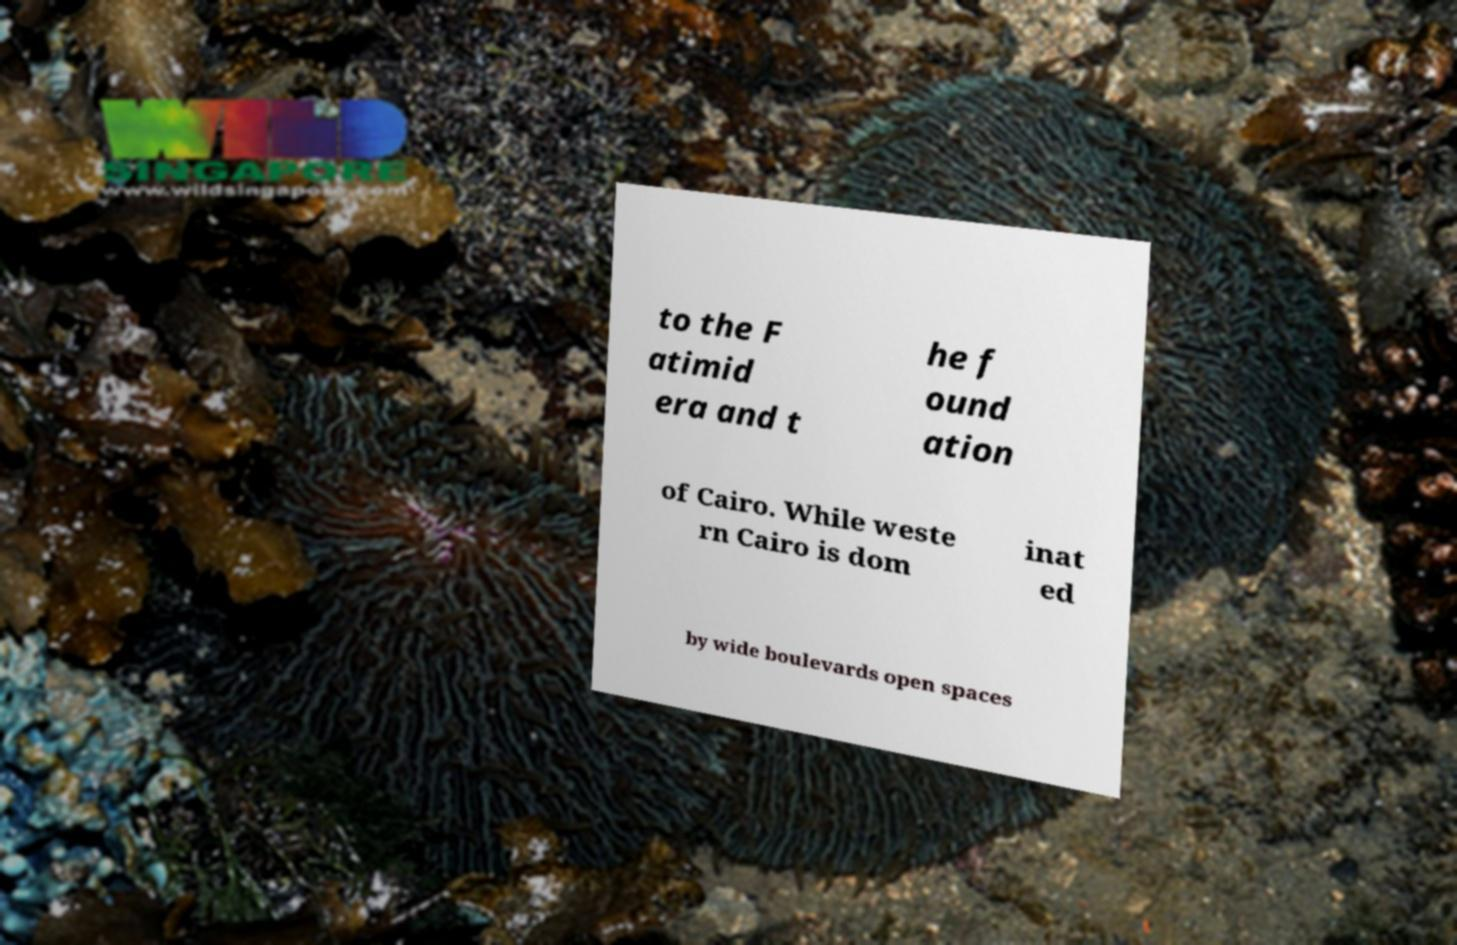Please read and relay the text visible in this image. What does it say? to the F atimid era and t he f ound ation of Cairo. While weste rn Cairo is dom inat ed by wide boulevards open spaces 